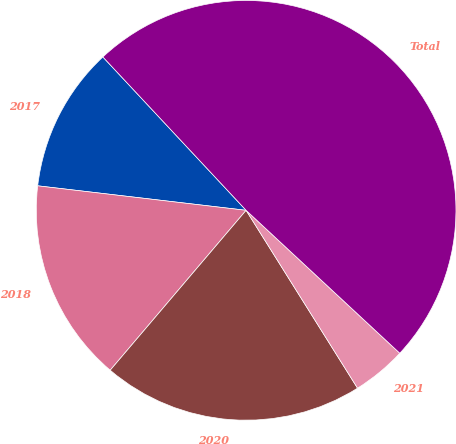<chart> <loc_0><loc_0><loc_500><loc_500><pie_chart><fcel>2017<fcel>2018<fcel>2020<fcel>2021<fcel>Total<nl><fcel>11.18%<fcel>15.65%<fcel>20.12%<fcel>4.17%<fcel>48.88%<nl></chart> 